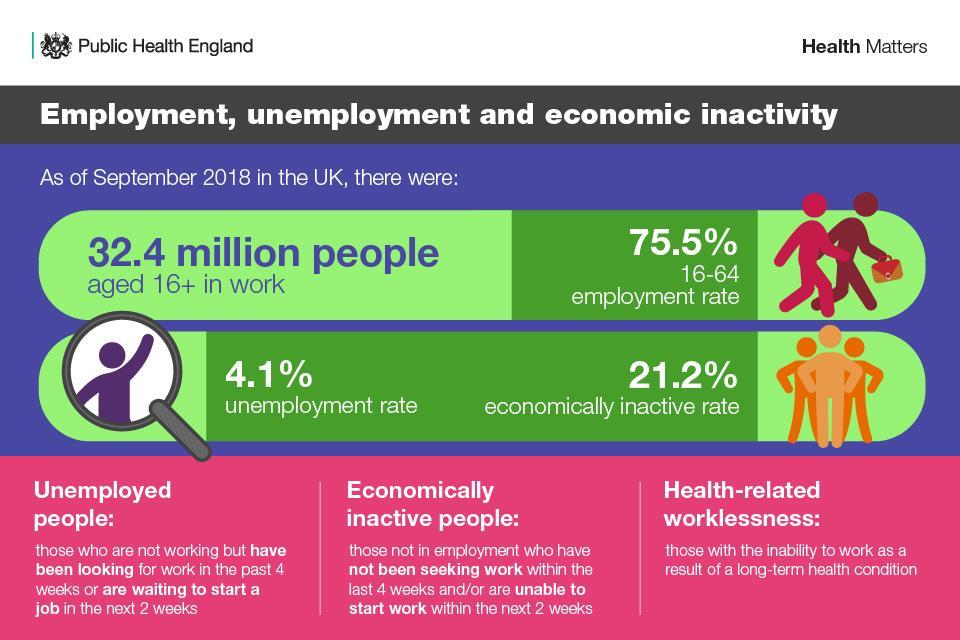What is the unemployment rate in the UK as of September 2018?
Answer the question with a short phrase. 4.1% What is the employment rate of people aged 16-64 years in the UK as of September 2018? 75.5% 